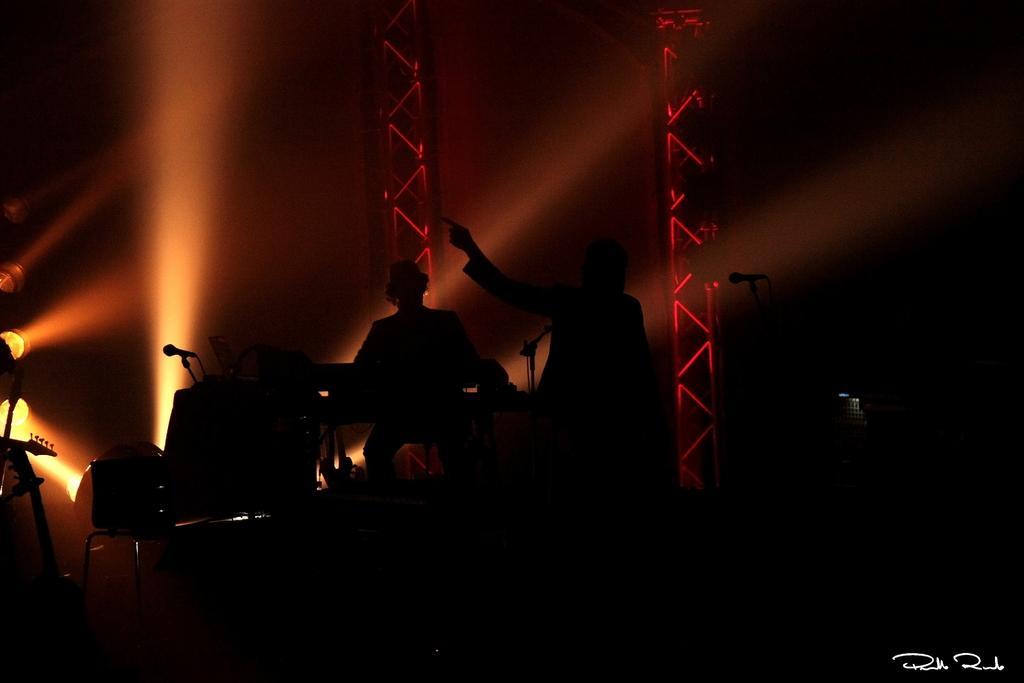Please provide a concise description of this image. In this picture we can see a person standing. There is a man sitting on a chair. We can see microphones, musical instruments and other objects. There are some lights visible on the left side. We can see some text in the bottom right. 